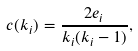Convert formula to latex. <formula><loc_0><loc_0><loc_500><loc_500>c ( k _ { i } ) = \frac { 2 e _ { i } } { k _ { i } ( k _ { i } - 1 ) } ,</formula> 